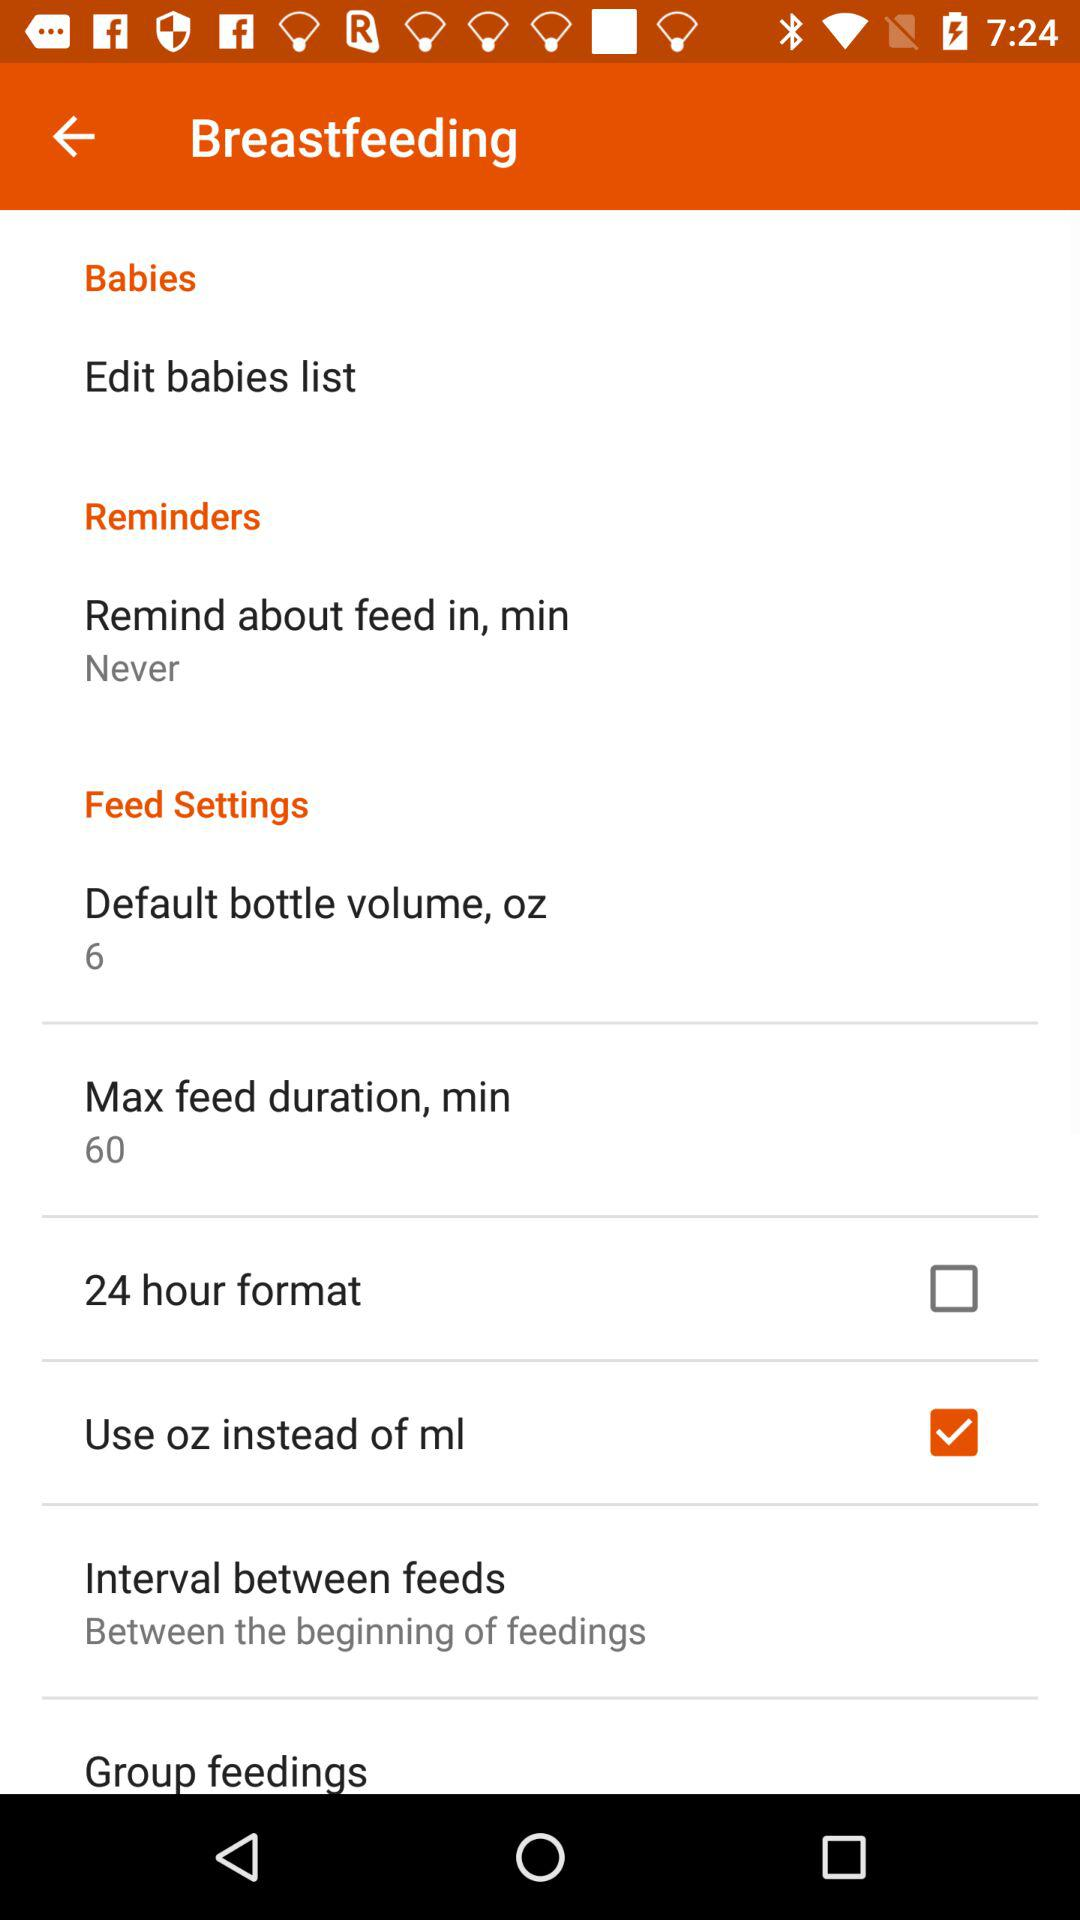What is the setting for "Remind about feed in, min"? The setting for "Remind about feed in, min" is "Never". 